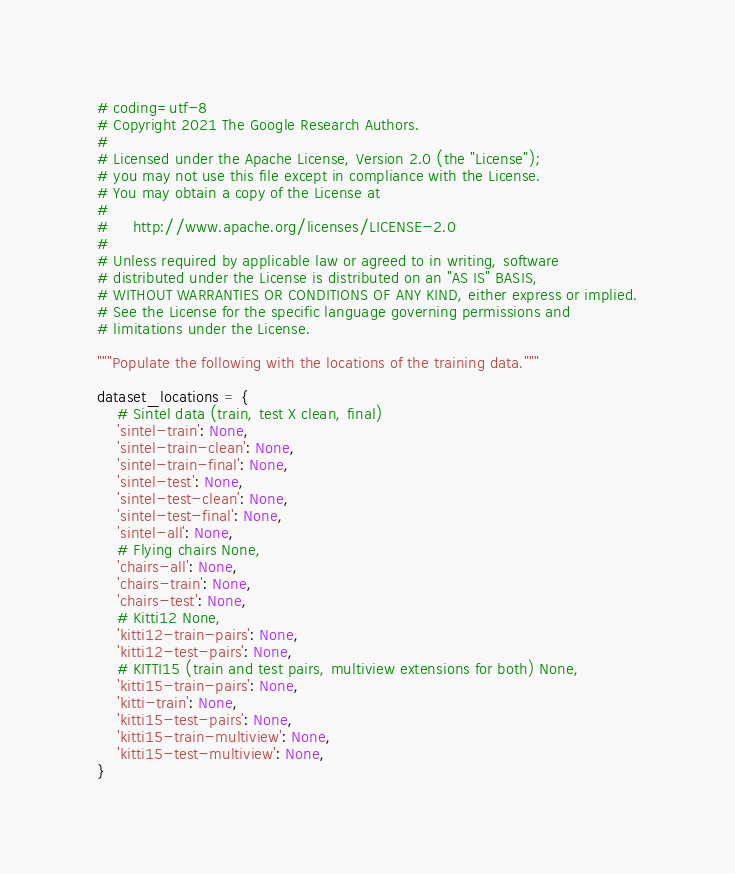Convert code to text. <code><loc_0><loc_0><loc_500><loc_500><_Python_># coding=utf-8
# Copyright 2021 The Google Research Authors.
#
# Licensed under the Apache License, Version 2.0 (the "License");
# you may not use this file except in compliance with the License.
# You may obtain a copy of the License at
#
#     http://www.apache.org/licenses/LICENSE-2.0
#
# Unless required by applicable law or agreed to in writing, software
# distributed under the License is distributed on an "AS IS" BASIS,
# WITHOUT WARRANTIES OR CONDITIONS OF ANY KIND, either express or implied.
# See the License for the specific language governing permissions and
# limitations under the License.

"""Populate the following with the locations of the training data."""

dataset_locations = {
    # Sintel data (train, test X clean, final)
    'sintel-train': None,
    'sintel-train-clean': None,
    'sintel-train-final': None,
    'sintel-test': None,
    'sintel-test-clean': None,
    'sintel-test-final': None,
    'sintel-all': None,
    # Flying chairs None,
    'chairs-all': None,
    'chairs-train': None,
    'chairs-test': None,
    # Kitti12 None,
    'kitti12-train-pairs': None,
    'kitti12-test-pairs': None,
    # KITTI15 (train and test pairs, multiview extensions for both) None,
    'kitti15-train-pairs': None,
    'kitti-train': None,
    'kitti15-test-pairs': None,
    'kitti15-train-multiview': None,
    'kitti15-test-multiview': None,
}
</code> 